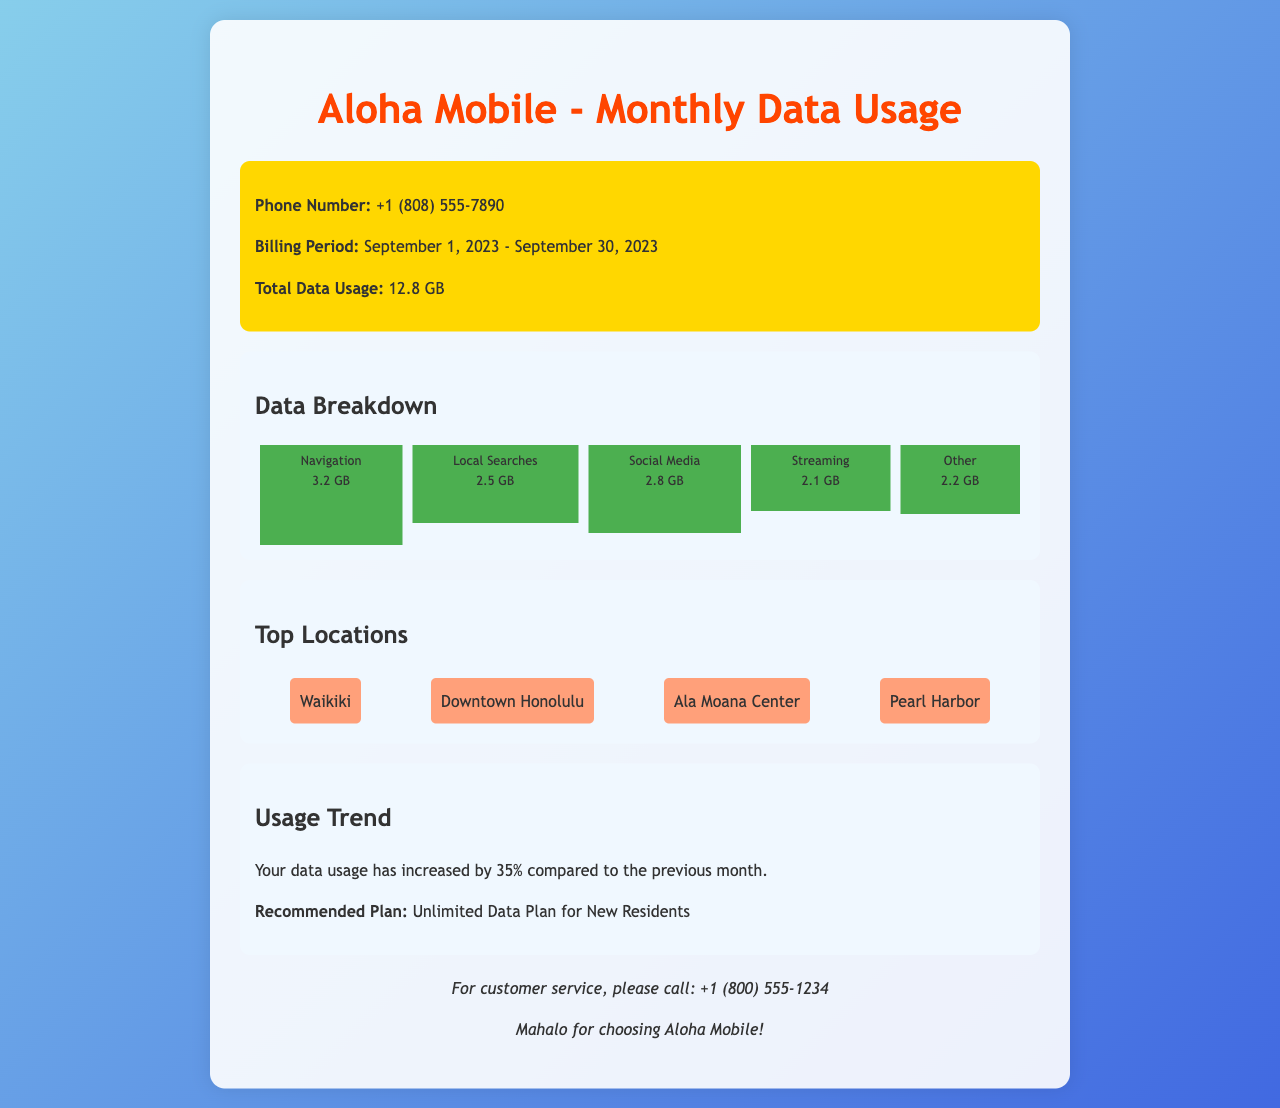What is the total data usage for September 2023? The total data usage is listed under "Total Data Usage" in the header section.
Answer: 12.8 GB How much data was used for navigation? The data used for navigation is shown in the data breakdown section specifically for "Navigation."
Answer: 3.2 GB What is the percentage increase in data usage compared to the previous month? The usage trend section states the percentage increase in data usage compared to the previous month.
Answer: 35% What is the recommended plan for new residents? The recommendation is provided in the usage trend section and specifies the type of plan suggested.
Answer: Unlimited Data Plan for New Residents Which location was not mentioned in the top locations? The document lists specific locations under the "Top Locations" section, and the question asks for one that is not listed.
Answer: Not Applicable (specific answer not given in the document) How much data was used for local searches? The data used for local searches is included in the data breakdown under "Local Searches."
Answer: 2.5 GB What is the phone number for customer service? The customer service contact is provided in the footer section of the document.
Answer: +1 (800) 555-1234 Which type of data usage consumed the least amount of data? The data usage breakdown shows various categories, and the question asks for the one with the least consumption.
Answer: Streaming 